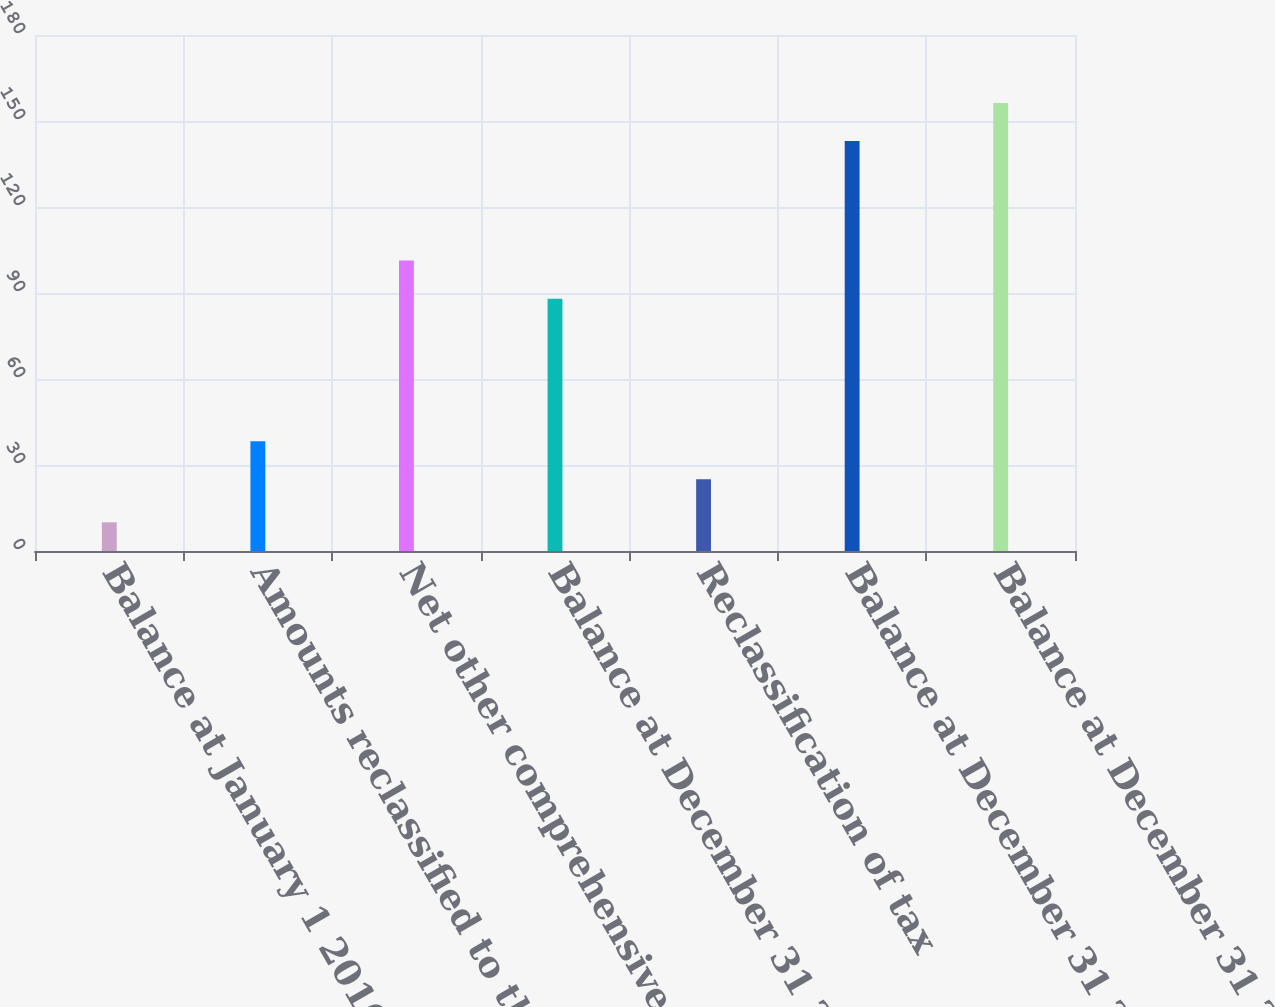Convert chart to OTSL. <chart><loc_0><loc_0><loc_500><loc_500><bar_chart><fcel>Balance at January 1 2016<fcel>Amounts reclassified to the<fcel>Net other comprehensive loss<fcel>Balance at December 31 2016<fcel>Reclassification of tax<fcel>Balance at December 31 2017<fcel>Balance at December 31 2018<nl><fcel>10<fcel>38.3<fcel>101.3<fcel>88<fcel>25<fcel>143<fcel>156.3<nl></chart> 